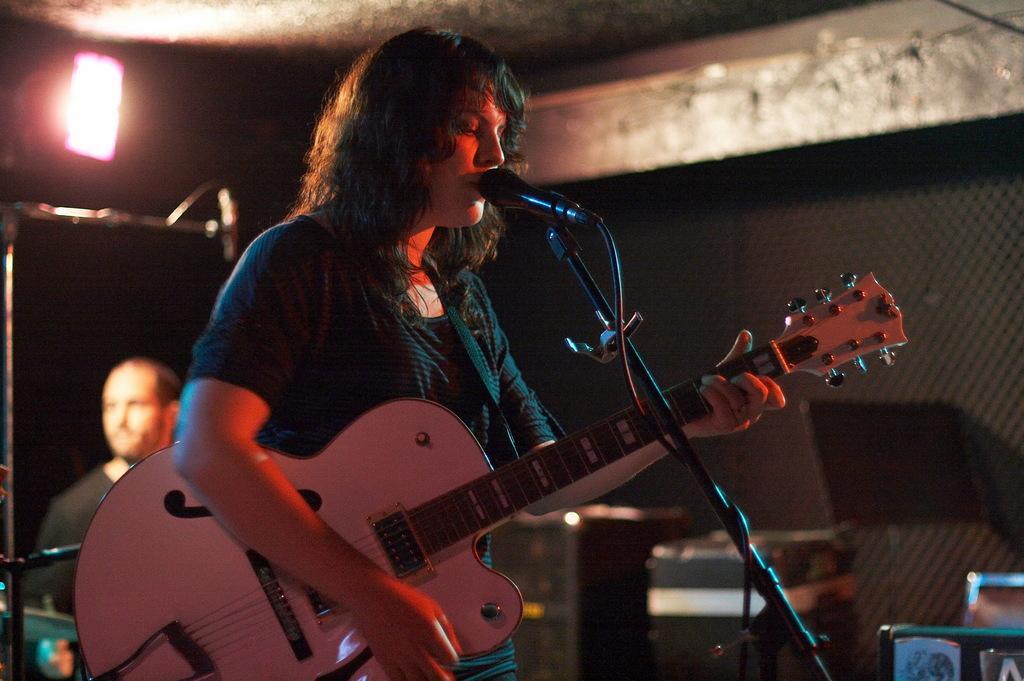Could you give a brief overview of what you see in this image? This picture is clicked in a musical concert. In front of the picture, woman in green t-shirt is holding guitar in her hands and she is playing it and she is even singing song on microphone. Beside her, we see two speaker boxes and behind her, we see a man in black t-shirt. On background, we see a black color sheet and on the left top of the picture, we see a light. 